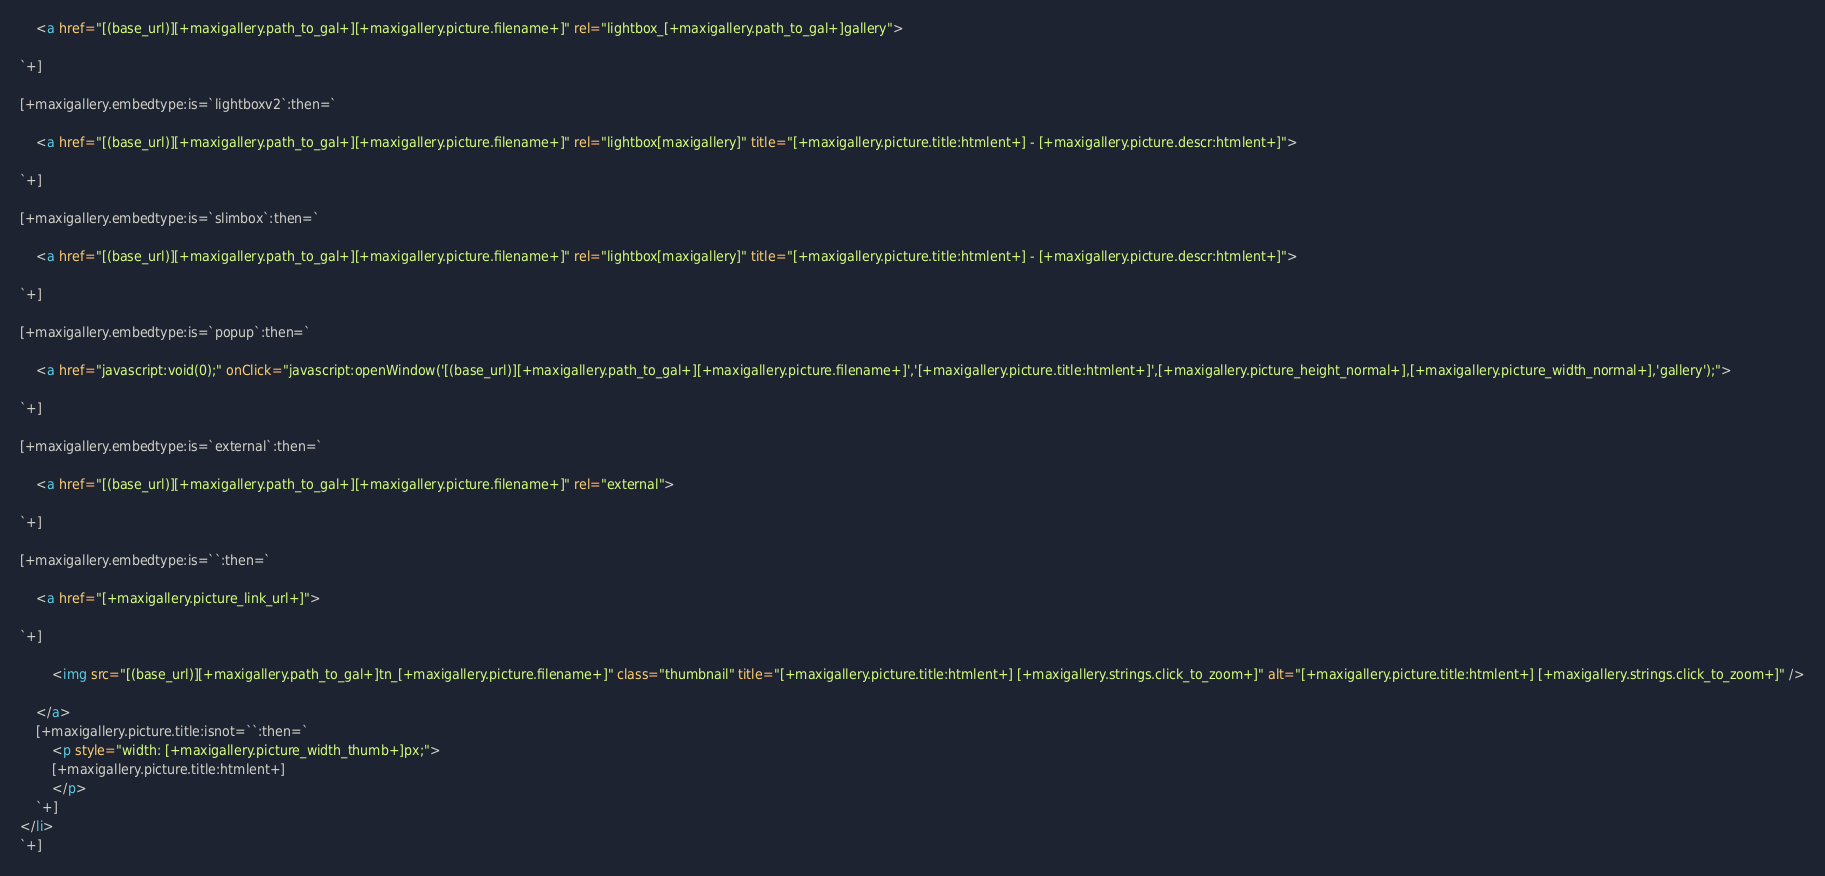<code> <loc_0><loc_0><loc_500><loc_500><_HTML_>	<a href="[(base_url)][+maxigallery.path_to_gal+][+maxigallery.picture.filename+]" rel="lightbox_[+maxigallery.path_to_gal+]gallery">

`+]

[+maxigallery.embedtype:is=`lightboxv2`:then=` 

	<a href="[(base_url)][+maxigallery.path_to_gal+][+maxigallery.picture.filename+]" rel="lightbox[maxigallery]" title="[+maxigallery.picture.title:htmlent+] - [+maxigallery.picture.descr:htmlent+]">

`+]

[+maxigallery.embedtype:is=`slimbox`:then=` 

	<a href="[(base_url)][+maxigallery.path_to_gal+][+maxigallery.picture.filename+]" rel="lightbox[maxigallery]" title="[+maxigallery.picture.title:htmlent+] - [+maxigallery.picture.descr:htmlent+]">

`+]

[+maxigallery.embedtype:is=`popup`:then=` 

	<a href="javascript:void(0);" onClick="javascript:openWindow('[(base_url)][+maxigallery.path_to_gal+][+maxigallery.picture.filename+]','[+maxigallery.picture.title:htmlent+]',[+maxigallery.picture_height_normal+],[+maxigallery.picture_width_normal+],'gallery');">

`+]

[+maxigallery.embedtype:is=`external`:then=` 

	<a href="[(base_url)][+maxigallery.path_to_gal+][+maxigallery.picture.filename+]" rel="external">

`+]

[+maxigallery.embedtype:is=``:then=`
	
	<a href="[+maxigallery.picture_link_url+]">

`+]
	
	 	<img src="[(base_url)][+maxigallery.path_to_gal+]tn_[+maxigallery.picture.filename+]" class="thumbnail" title="[+maxigallery.picture.title:htmlent+] [+maxigallery.strings.click_to_zoom+]" alt="[+maxigallery.picture.title:htmlent+] [+maxigallery.strings.click_to_zoom+]" />
	
	</a>
	[+maxigallery.picture.title:isnot=``:then=`
		<p style="width: [+maxigallery.picture_width_thumb+]px;">
		[+maxigallery.picture.title:htmlent+]
		</p>
	`+]
</li>
`+]</code> 